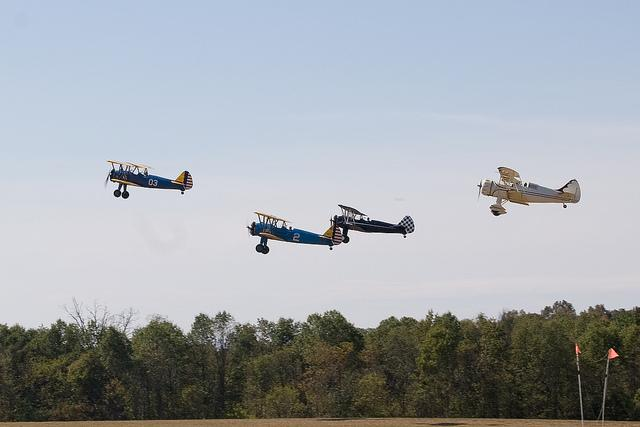What type of activities are happening here? Please explain your reasoning. aviation. Several planes are in the air flying in formation. 